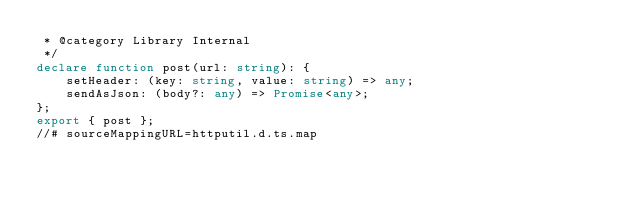<code> <loc_0><loc_0><loc_500><loc_500><_TypeScript_> * @category Library Internal
 */
declare function post(url: string): {
    setHeader: (key: string, value: string) => any;
    sendAsJson: (body?: any) => Promise<any>;
};
export { post };
//# sourceMappingURL=httputil.d.ts.map</code> 